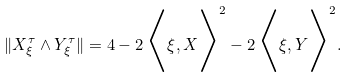<formula> <loc_0><loc_0><loc_500><loc_500>\| X _ { \xi } ^ { \tau } \wedge Y _ { \xi } ^ { \tau } \| = 4 - 2 \, \Big < \xi , X \Big > ^ { 2 } - 2 \, \Big < \xi , Y \Big > ^ { 2 } .</formula> 